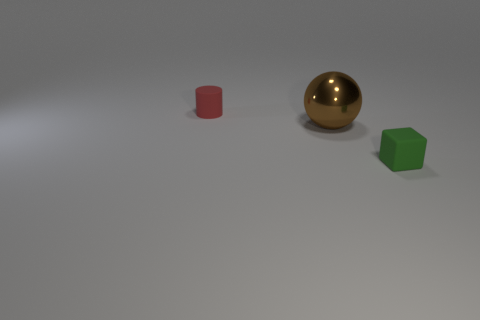There is a green thing that is the same size as the red object; what is its shape?
Ensure brevity in your answer.  Cube. Are there any brown metal things of the same shape as the red matte thing?
Give a very brief answer. No. There is a tiny object in front of the small object to the left of the tiny green object; are there any tiny red cylinders that are behind it?
Offer a terse response. Yes. Are there more small things that are on the right side of the brown metallic thing than small rubber blocks behind the green thing?
Make the answer very short. Yes. How many big objects are either blocks or cyan blocks?
Ensure brevity in your answer.  0. Do the tiny red rubber thing and the shiny thing have the same shape?
Offer a terse response. No. What number of objects are both on the left side of the tiny green rubber thing and in front of the red object?
Your answer should be very brief. 1. Is there any other thing that is the same color as the block?
Offer a terse response. No. The small red object that is the same material as the green cube is what shape?
Give a very brief answer. Cylinder. Do the red rubber cylinder and the green rubber thing have the same size?
Offer a very short reply. Yes. 